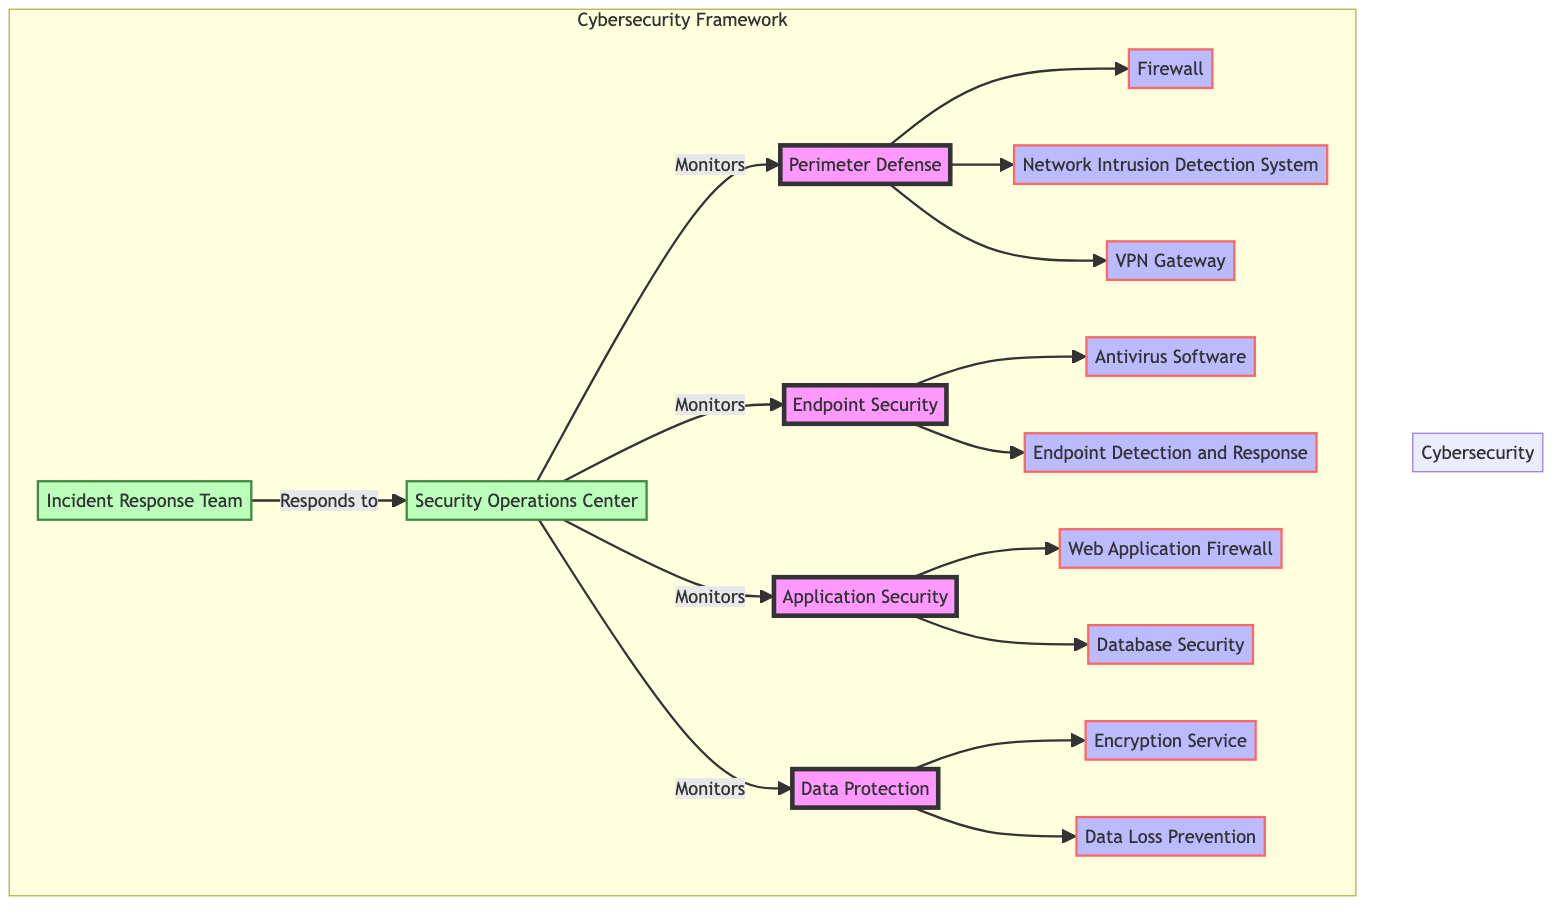What is the first layer in the cybersecurity framework? The first layer listed in the diagram is "Perimeter Defense," which is the top-most layer in the structure.
Answer: Perimeter Defense How many components are in the Endpoint Security layer? The Endpoint Security layer has two components: Antivirus Software and Endpoint Detection and Response. This can be counted directly from the diagram.
Answer: 2 What team responds to the Security Operations Center? The Incident Response Team (IRT) responds to the Security Operations Center (SOC) as shown by the directed edge in the diagram.
Answer: Incident Response Team Which real-world entity is associated with the Web Application Firewall component? The real-world entity associated with the Web Application Firewall component is "F5 BIG-IP ASM," as listed under the Application Security layer.
Answer: F5 BIG-IP ASM How many incident response teams are shown in the diagram? There are two incident response teams represented in the diagram: the Security Operations Center (SOC) and the Incident Response Team (IRT).
Answer: 2 What function is associated with the Security Operations Center? One of the functions associated with the Security Operations Center (SOC) is "24/7 Monitoring," which is explicitly mentioned in the diagram.
Answer: 24/7 Monitoring What cybersecurity layer is monitored by the SOC based on the diagram? The Security Operations Center (SOC) monitors all four layers: Perimeter Defense, Endpoint Security, Application Security, and Data Protection, as indicated by the arrows in the diagram showing connections to all these layers.
Answer: All four layers Which component in Data Protection is associated with encryption? The component associated with encryption in the Data Protection layer is "Encryption Service," which directly points to its specific real-world entity, Microsoft Azure Key Vault.
Answer: Encryption Service What location is the Incident Response Team based in? The Incident Response Team (IRT) is based in New York, NY, as specified in the diagram's descriptions.
Answer: New York, NY 